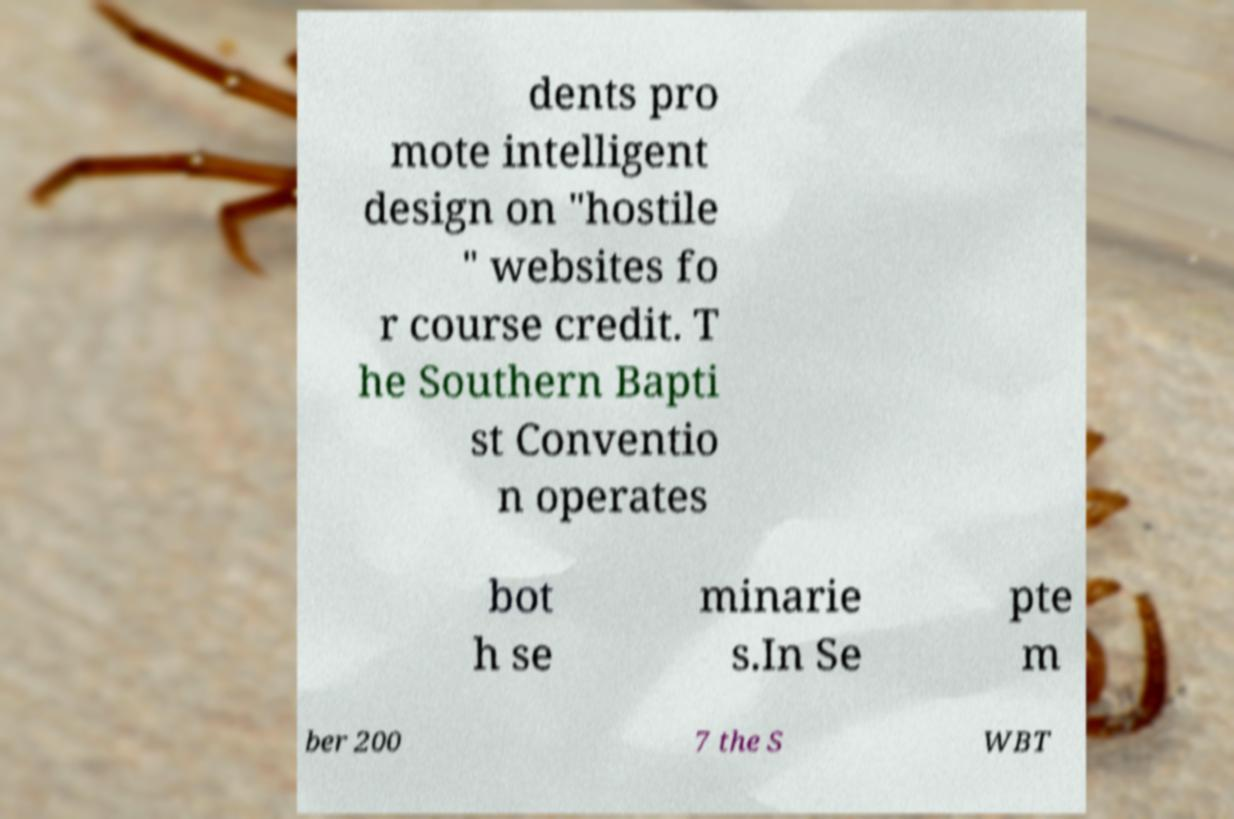For documentation purposes, I need the text within this image transcribed. Could you provide that? dents pro mote intelligent design on "hostile " websites fo r course credit. T he Southern Bapti st Conventio n operates bot h se minarie s.In Se pte m ber 200 7 the S WBT 